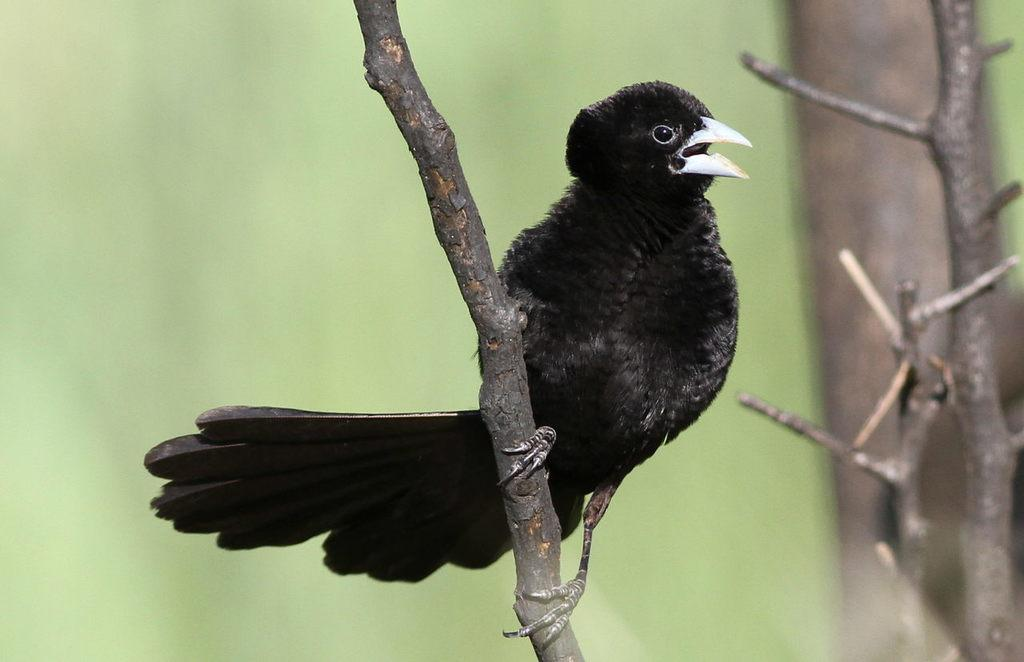What type of animal can be seen in the image? There is a bird in the image. Where is the bird located in the image? The bird is on the branch of a tree. What color is predominant in the background of the image? The background of the image is green. What is the price of the bird in the image? There is no price associated with the bird in the image, as it is a photograph and not a product for sale. 